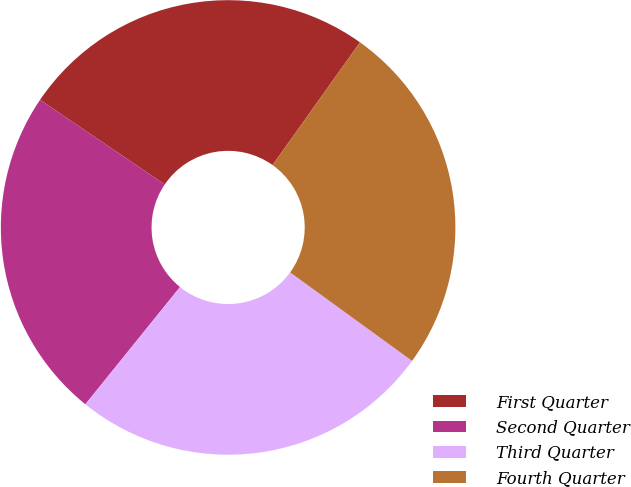<chart> <loc_0><loc_0><loc_500><loc_500><pie_chart><fcel>First Quarter<fcel>Second Quarter<fcel>Third Quarter<fcel>Fourth Quarter<nl><fcel>25.36%<fcel>23.68%<fcel>25.82%<fcel>25.14%<nl></chart> 